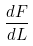<formula> <loc_0><loc_0><loc_500><loc_500>\frac { d F } { d L }</formula> 